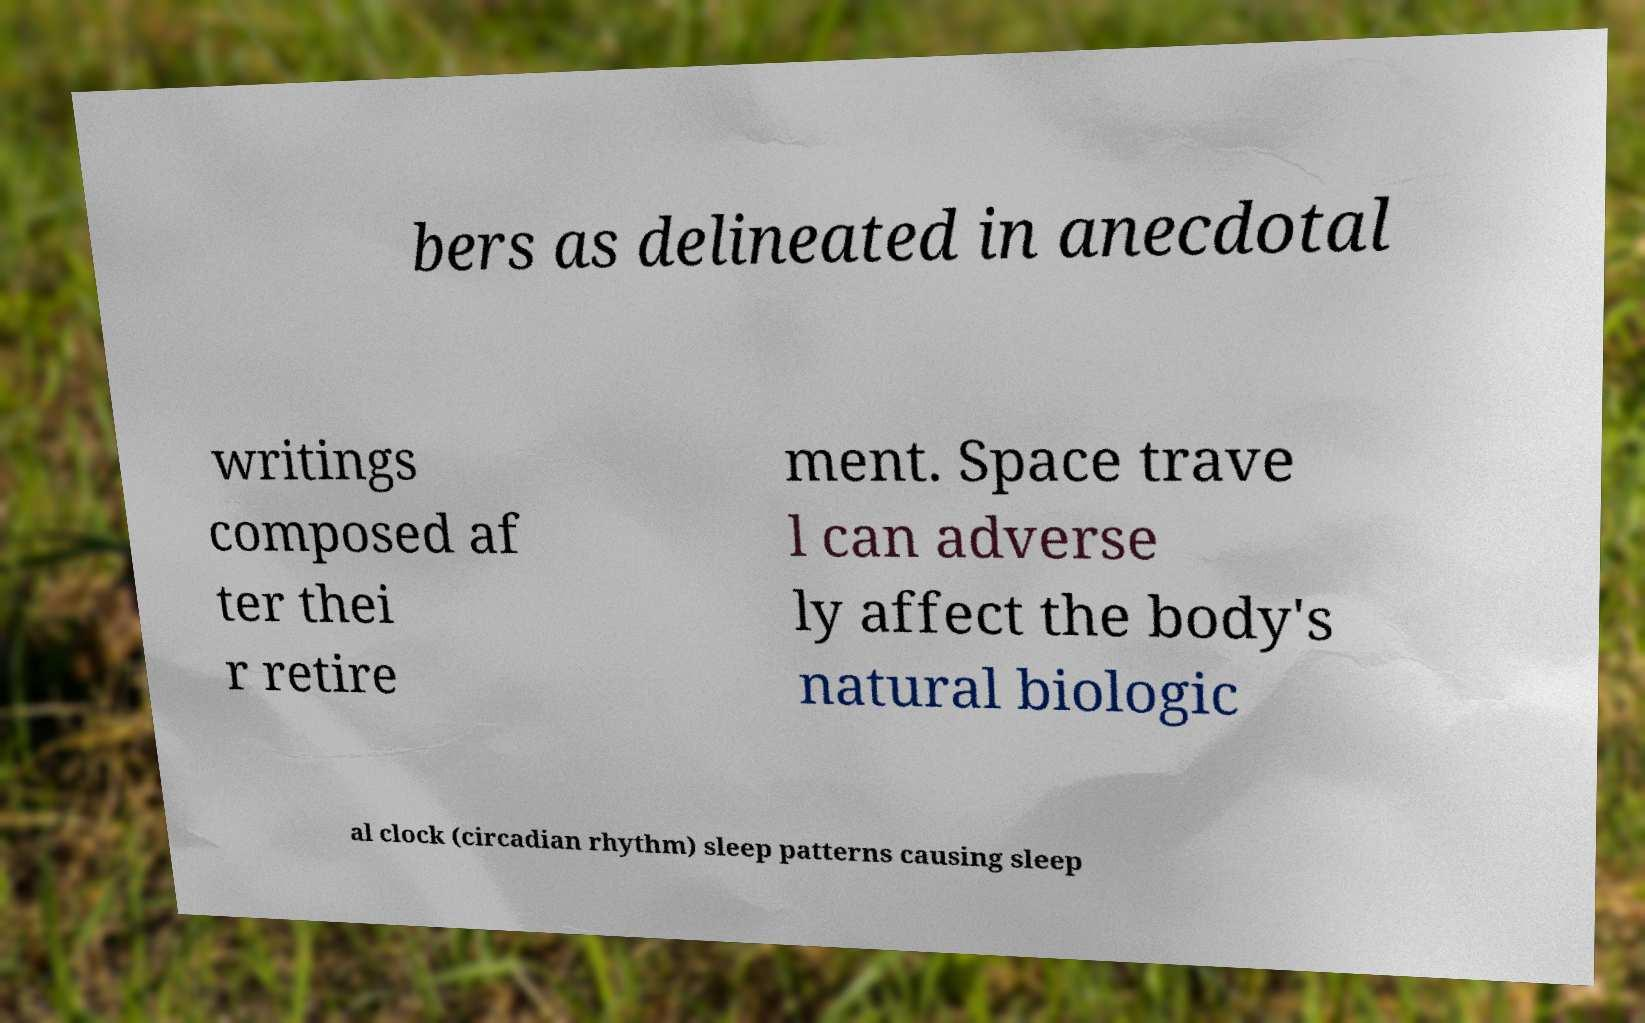Could you assist in decoding the text presented in this image and type it out clearly? bers as delineated in anecdotal writings composed af ter thei r retire ment. Space trave l can adverse ly affect the body's natural biologic al clock (circadian rhythm) sleep patterns causing sleep 